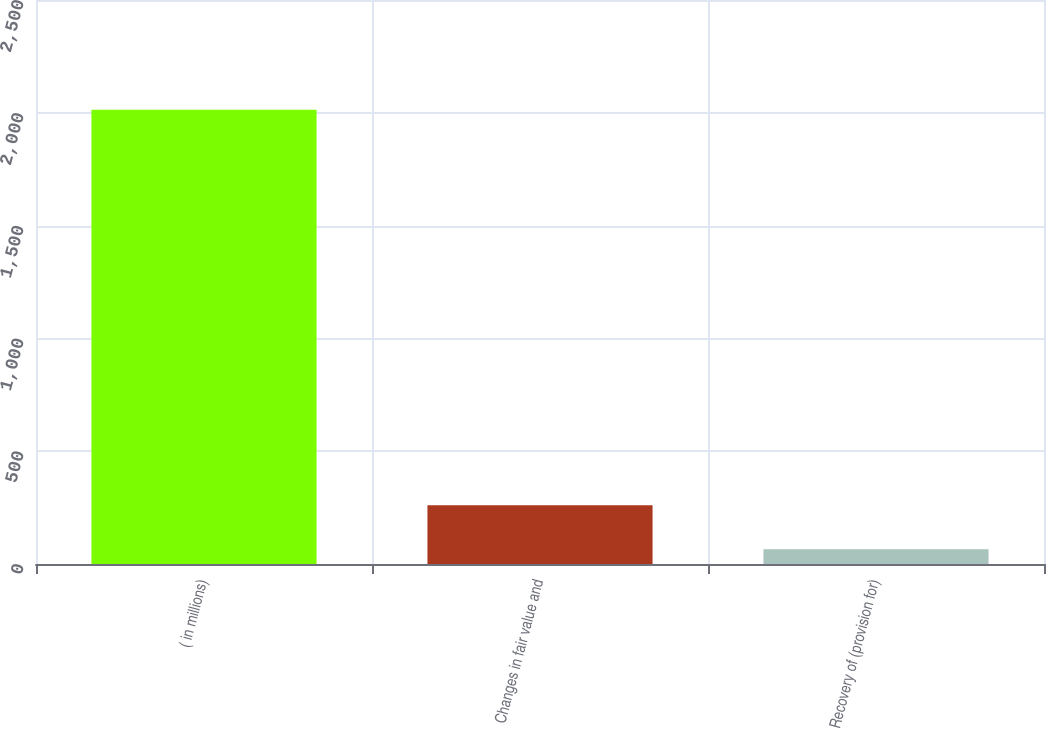<chart> <loc_0><loc_0><loc_500><loc_500><bar_chart><fcel>( in millions)<fcel>Changes in fair value and<fcel>Recovery of (provision for)<nl><fcel>2014<fcel>259.9<fcel>65<nl></chart> 